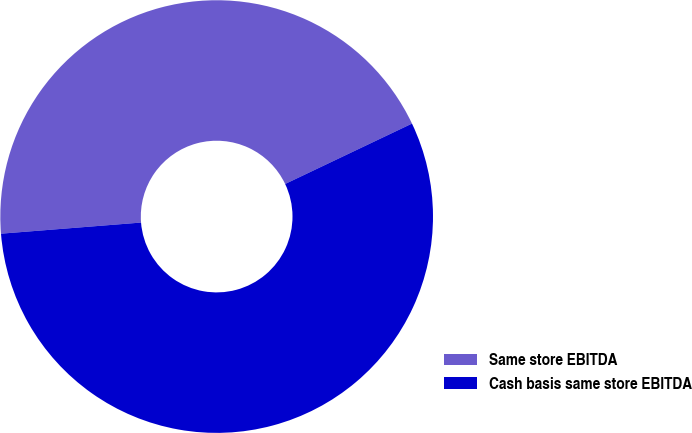Convert chart to OTSL. <chart><loc_0><loc_0><loc_500><loc_500><pie_chart><fcel>Same store EBITDA<fcel>Cash basis same store EBITDA<nl><fcel>44.19%<fcel>55.81%<nl></chart> 